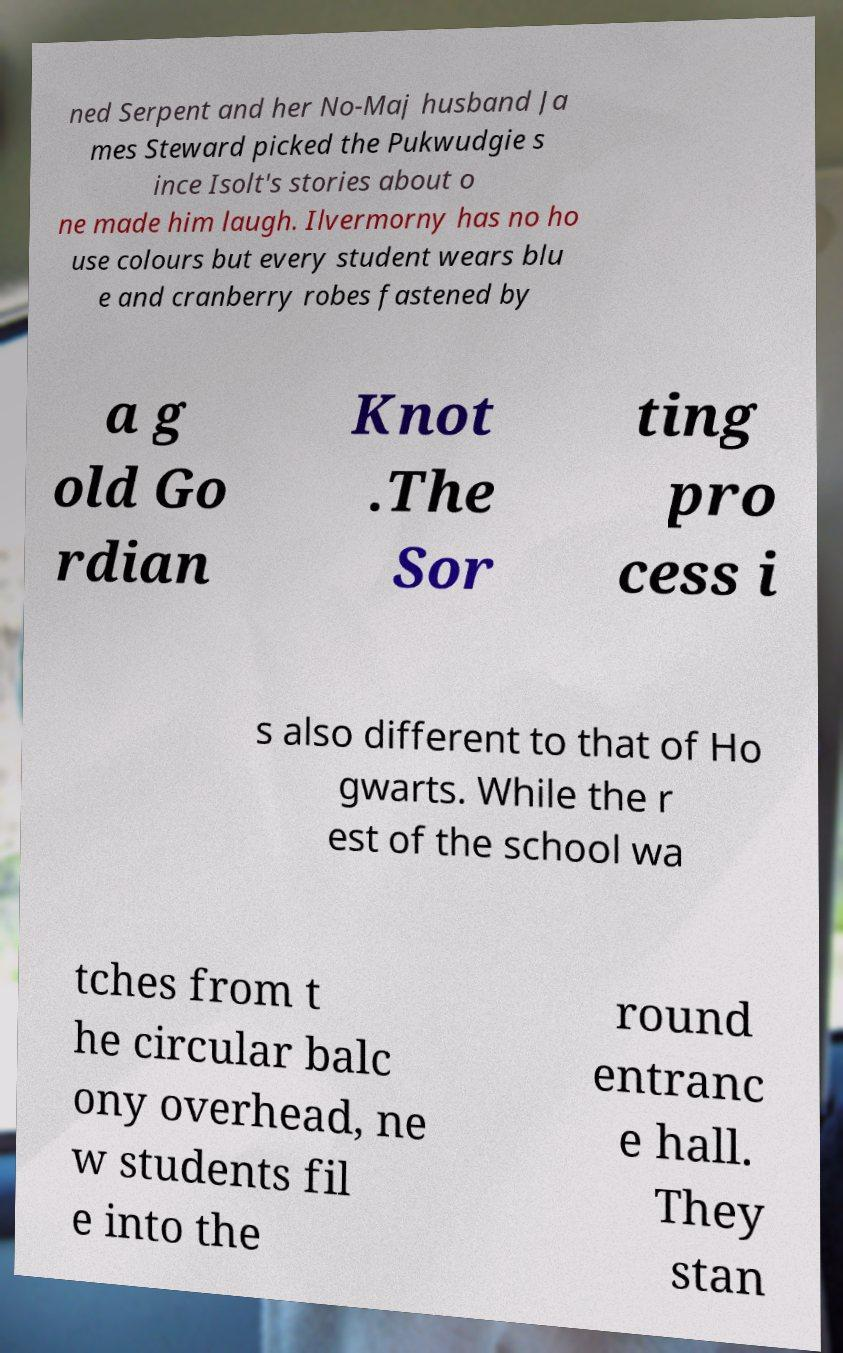There's text embedded in this image that I need extracted. Can you transcribe it verbatim? ned Serpent and her No-Maj husband Ja mes Steward picked the Pukwudgie s ince Isolt's stories about o ne made him laugh. Ilvermorny has no ho use colours but every student wears blu e and cranberry robes fastened by a g old Go rdian Knot .The Sor ting pro cess i s also different to that of Ho gwarts. While the r est of the school wa tches from t he circular balc ony overhead, ne w students fil e into the round entranc e hall. They stan 